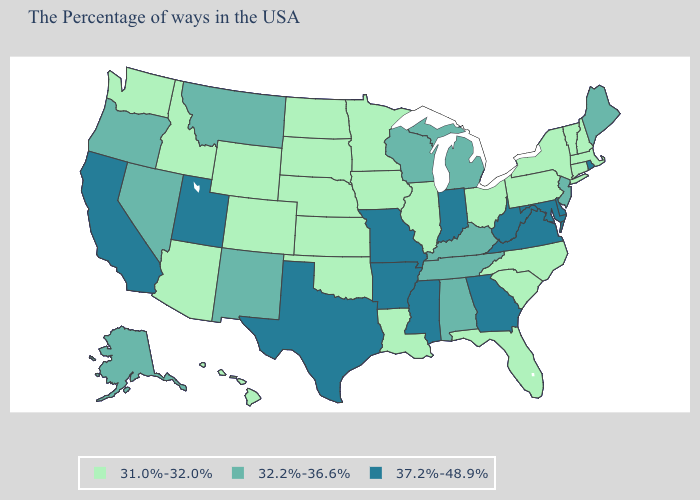What is the value of Illinois?
Be succinct. 31.0%-32.0%. What is the lowest value in states that border Montana?
Answer briefly. 31.0%-32.0%. Which states hav the highest value in the West?
Answer briefly. Utah, California. Name the states that have a value in the range 31.0%-32.0%?
Short answer required. Massachusetts, New Hampshire, Vermont, Connecticut, New York, Pennsylvania, North Carolina, South Carolina, Ohio, Florida, Illinois, Louisiana, Minnesota, Iowa, Kansas, Nebraska, Oklahoma, South Dakota, North Dakota, Wyoming, Colorado, Arizona, Idaho, Washington, Hawaii. Does New Mexico have the highest value in the USA?
Short answer required. No. Does the map have missing data?
Quick response, please. No. Name the states that have a value in the range 37.2%-48.9%?
Quick response, please. Rhode Island, Delaware, Maryland, Virginia, West Virginia, Georgia, Indiana, Mississippi, Missouri, Arkansas, Texas, Utah, California. Does Washington have the lowest value in the USA?
Give a very brief answer. Yes. Does Georgia have the highest value in the USA?
Answer briefly. Yes. How many symbols are there in the legend?
Keep it brief. 3. What is the value of Texas?
Write a very short answer. 37.2%-48.9%. What is the lowest value in states that border Florida?
Be succinct. 32.2%-36.6%. What is the highest value in the USA?
Concise answer only. 37.2%-48.9%. Name the states that have a value in the range 37.2%-48.9%?
Write a very short answer. Rhode Island, Delaware, Maryland, Virginia, West Virginia, Georgia, Indiana, Mississippi, Missouri, Arkansas, Texas, Utah, California. What is the highest value in the USA?
Give a very brief answer. 37.2%-48.9%. 